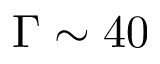<formula> <loc_0><loc_0><loc_500><loc_500>\Gamma \sim 4 0</formula> 